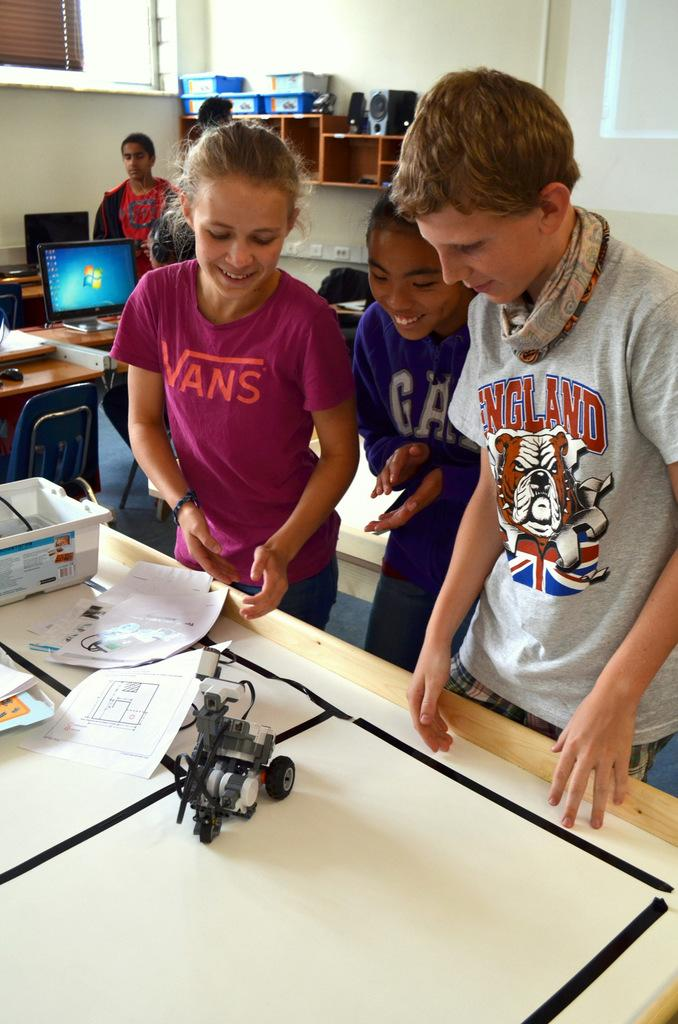How many children are in the image? There are two girls and one boy in the image. What are the children doing in the image? The children are standing and playing with a toy on a table. What electronic device is visible in the image? There is a monitor visible in the image. Who else is present in the image besides the children? There is a woman standing in the image. What type of story is the coach telling the children in the image? There is no coach or story present in the image; it features children playing with a toy on a table and a woman standing nearby. What type of pump is visible in the image? There is no pump present in the image. 